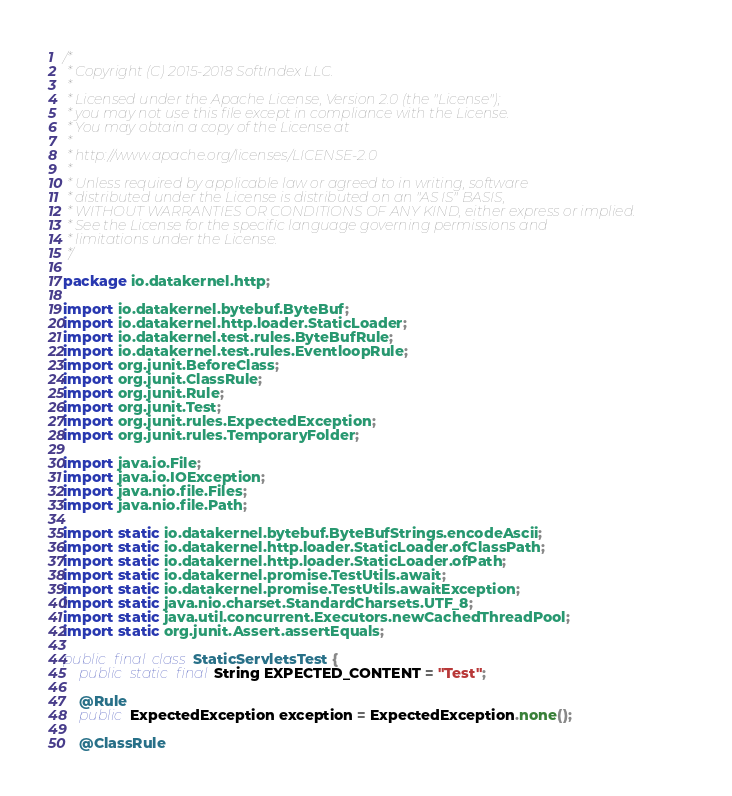Convert code to text. <code><loc_0><loc_0><loc_500><loc_500><_Java_>/*
 * Copyright (C) 2015-2018 SoftIndex LLC.
 *
 * Licensed under the Apache License, Version 2.0 (the "License");
 * you may not use this file except in compliance with the License.
 * You may obtain a copy of the License at
 *
 * http://www.apache.org/licenses/LICENSE-2.0
 *
 * Unless required by applicable law or agreed to in writing, software
 * distributed under the License is distributed on an "AS IS" BASIS,
 * WITHOUT WARRANTIES OR CONDITIONS OF ANY KIND, either express or implied.
 * See the License for the specific language governing permissions and
 * limitations under the License.
 */

package io.datakernel.http;

import io.datakernel.bytebuf.ByteBuf;
import io.datakernel.http.loader.StaticLoader;
import io.datakernel.test.rules.ByteBufRule;
import io.datakernel.test.rules.EventloopRule;
import org.junit.BeforeClass;
import org.junit.ClassRule;
import org.junit.Rule;
import org.junit.Test;
import org.junit.rules.ExpectedException;
import org.junit.rules.TemporaryFolder;

import java.io.File;
import java.io.IOException;
import java.nio.file.Files;
import java.nio.file.Path;

import static io.datakernel.bytebuf.ByteBufStrings.encodeAscii;
import static io.datakernel.http.loader.StaticLoader.ofClassPath;
import static io.datakernel.http.loader.StaticLoader.ofPath;
import static io.datakernel.promise.TestUtils.await;
import static io.datakernel.promise.TestUtils.awaitException;
import static java.nio.charset.StandardCharsets.UTF_8;
import static java.util.concurrent.Executors.newCachedThreadPool;
import static org.junit.Assert.assertEquals;

public final class StaticServletsTest {
	public static final String EXPECTED_CONTENT = "Test";

	@Rule
	public ExpectedException exception = ExpectedException.none();

	@ClassRule</code> 